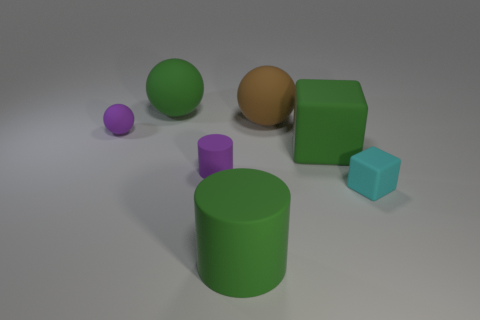There is a rubber object that is the same color as the tiny sphere; what shape is it?
Give a very brief answer. Cylinder. Are any big things visible?
Your answer should be very brief. Yes. What number of matte cylinders have the same size as the cyan cube?
Make the answer very short. 1. How many matte objects are both in front of the green block and to the right of the big brown sphere?
Your response must be concise. 1. Do the cylinder that is behind the green matte cylinder and the large brown sphere have the same size?
Give a very brief answer. No. Is there a cube of the same color as the big rubber cylinder?
Your response must be concise. Yes. What size is the purple cylinder that is the same material as the cyan object?
Make the answer very short. Small. Are there more rubber things that are right of the large green matte cube than large brown balls that are to the left of the green rubber ball?
Your answer should be very brief. Yes. How many other things are there of the same material as the cyan block?
Your answer should be very brief. 6. Is the small purple thing in front of the small purple rubber sphere made of the same material as the small cyan thing?
Give a very brief answer. Yes. 